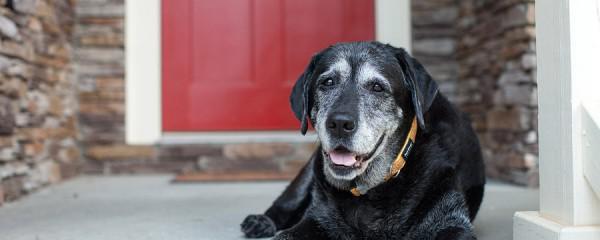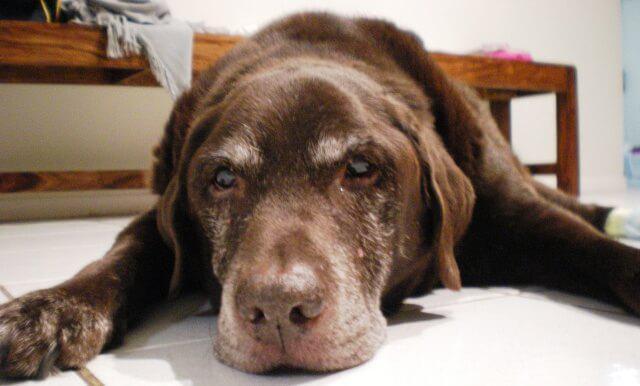The first image is the image on the left, the second image is the image on the right. Examine the images to the left and right. Is the description "There is one black dog that has its mouth open in one of the images." accurate? Answer yes or no. Yes. The first image is the image on the left, the second image is the image on the right. For the images shown, is this caption "One image contains exactly one reclining chocolate-brown dog." true? Answer yes or no. Yes. 